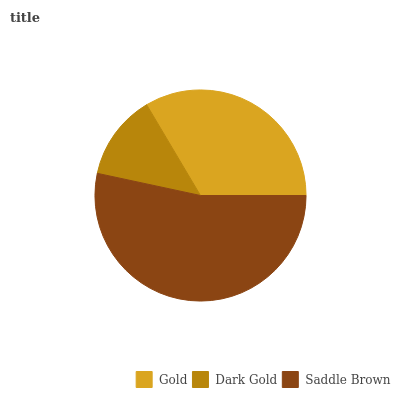Is Dark Gold the minimum?
Answer yes or no. Yes. Is Saddle Brown the maximum?
Answer yes or no. Yes. Is Saddle Brown the minimum?
Answer yes or no. No. Is Dark Gold the maximum?
Answer yes or no. No. Is Saddle Brown greater than Dark Gold?
Answer yes or no. Yes. Is Dark Gold less than Saddle Brown?
Answer yes or no. Yes. Is Dark Gold greater than Saddle Brown?
Answer yes or no. No. Is Saddle Brown less than Dark Gold?
Answer yes or no. No. Is Gold the high median?
Answer yes or no. Yes. Is Gold the low median?
Answer yes or no. Yes. Is Dark Gold the high median?
Answer yes or no. No. Is Saddle Brown the low median?
Answer yes or no. No. 